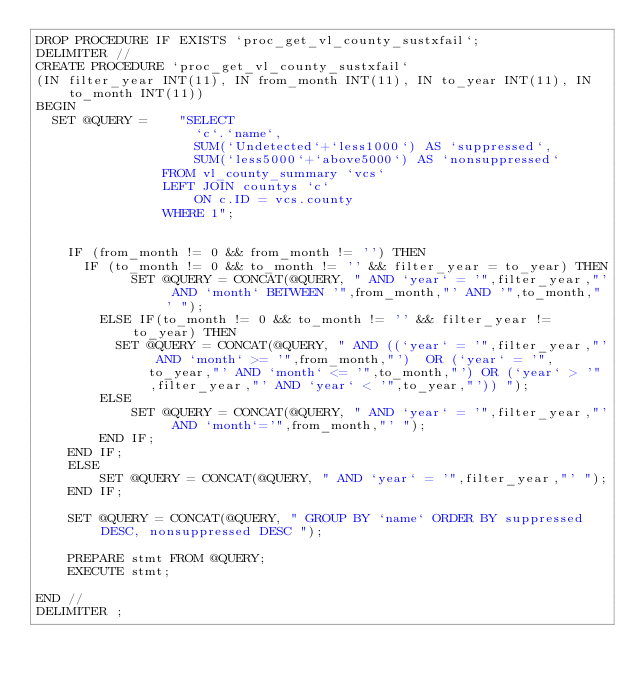<code> <loc_0><loc_0><loc_500><loc_500><_SQL_>DROP PROCEDURE IF EXISTS `proc_get_vl_county_sustxfail`;
DELIMITER //
CREATE PROCEDURE `proc_get_vl_county_sustxfail`
(IN filter_year INT(11), IN from_month INT(11), IN to_year INT(11), IN to_month INT(11))
BEGIN
  SET @QUERY =    "SELECT 
                    `c`.`name`,
                    SUM(`Undetected`+`less1000`) AS `suppressed`,
                    SUM(`less5000`+`above5000`) AS `nonsuppressed`
                FROM vl_county_summary `vcs`
                LEFT JOIN countys `c`
                    ON c.ID = vcs.county
                WHERE 1";

   
    IF (from_month != 0 && from_month != '') THEN
      IF (to_month != 0 && to_month != '' && filter_year = to_year) THEN
            SET @QUERY = CONCAT(@QUERY, " AND `year` = '",filter_year,"' AND `month` BETWEEN '",from_month,"' AND '",to_month,"' ");
        ELSE IF(to_month != 0 && to_month != '' && filter_year != to_year) THEN
          SET @QUERY = CONCAT(@QUERY, " AND ((`year` = '",filter_year,"' AND `month` >= '",from_month,"')  OR (`year` = '",to_year,"' AND `month` <= '",to_month,"') OR (`year` > '",filter_year,"' AND `year` < '",to_year,"')) ");
        ELSE
            SET @QUERY = CONCAT(@QUERY, " AND `year` = '",filter_year,"' AND `month`='",from_month,"' ");
        END IF;
    END IF;
    ELSE
        SET @QUERY = CONCAT(@QUERY, " AND `year` = '",filter_year,"' ");
    END IF;

    SET @QUERY = CONCAT(@QUERY, " GROUP BY `name` ORDER BY suppressed DESC, nonsuppressed DESC ");

    PREPARE stmt FROM @QUERY;
    EXECUTE stmt;
    
END //
DELIMITER ;
</code> 